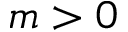<formula> <loc_0><loc_0><loc_500><loc_500>m > 0</formula> 